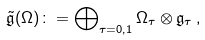Convert formula to latex. <formula><loc_0><loc_0><loc_500><loc_500>\tilde { \mathfrak { g } } ( \Omega ) \colon = \bigoplus \nolimits _ { \tau = 0 , 1 } \Omega _ { \tau } \otimes \mathfrak { g } _ { \tau } \, ,</formula> 